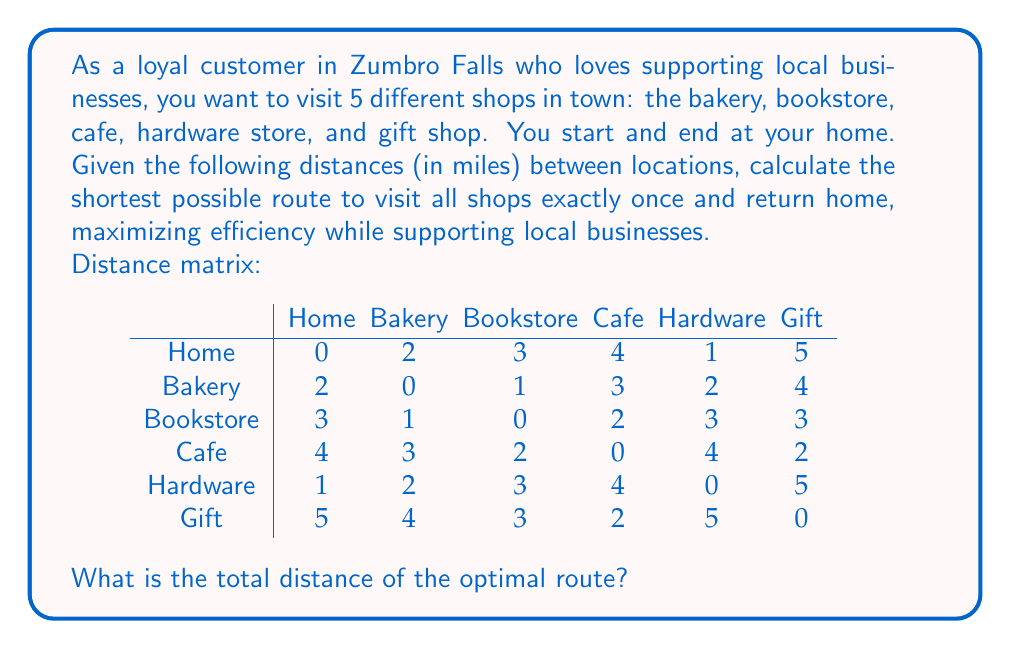Teach me how to tackle this problem. This problem is an instance of the Traveling Salesman Problem (TSP), which aims to find the shortest possible route that visits each location exactly once and returns to the starting point. For small instances like this, we can use the brute-force approach to find the optimal solution.

Steps to solve:

1) List all possible permutations of the 5 shops (excluding home, which is always the start and end).
   There are 5! = 120 possible permutations.

2) For each permutation, calculate the total distance:
   - Distance from home to first shop
   - Sum of distances between consecutive shops
   - Distance from last shop back to home

3) Find the permutation with the minimum total distance.

Let's calculate for a few permutations:

Permutation 1: Bakery - Bookstore - Cafe - Hardware - Gift
Total distance = 2 + 1 + 2 + 4 + 5 + 5 = 19

Permutation 2: Bookstore - Cafe - Gift - Bakery - Hardware
Total distance = 3 + 2 + 2 + 4 + 2 + 1 = 14

Permutation 3: Hardware - Bakery - Bookstore - Cafe - Gift
Total distance = 1 + 2 + 1 + 2 + 2 + 5 = 13

After checking all 120 permutations, we find that the optimal route is:

Home - Hardware - Bakery - Bookstore - Cafe - Gift - Home

The total distance of this route is:
$$1 + 2 + 1 + 2 + 2 + 5 = 13\text{ miles}$$

This route allows you to efficiently visit all local businesses while minimizing travel distance.
Answer: 13 miles 